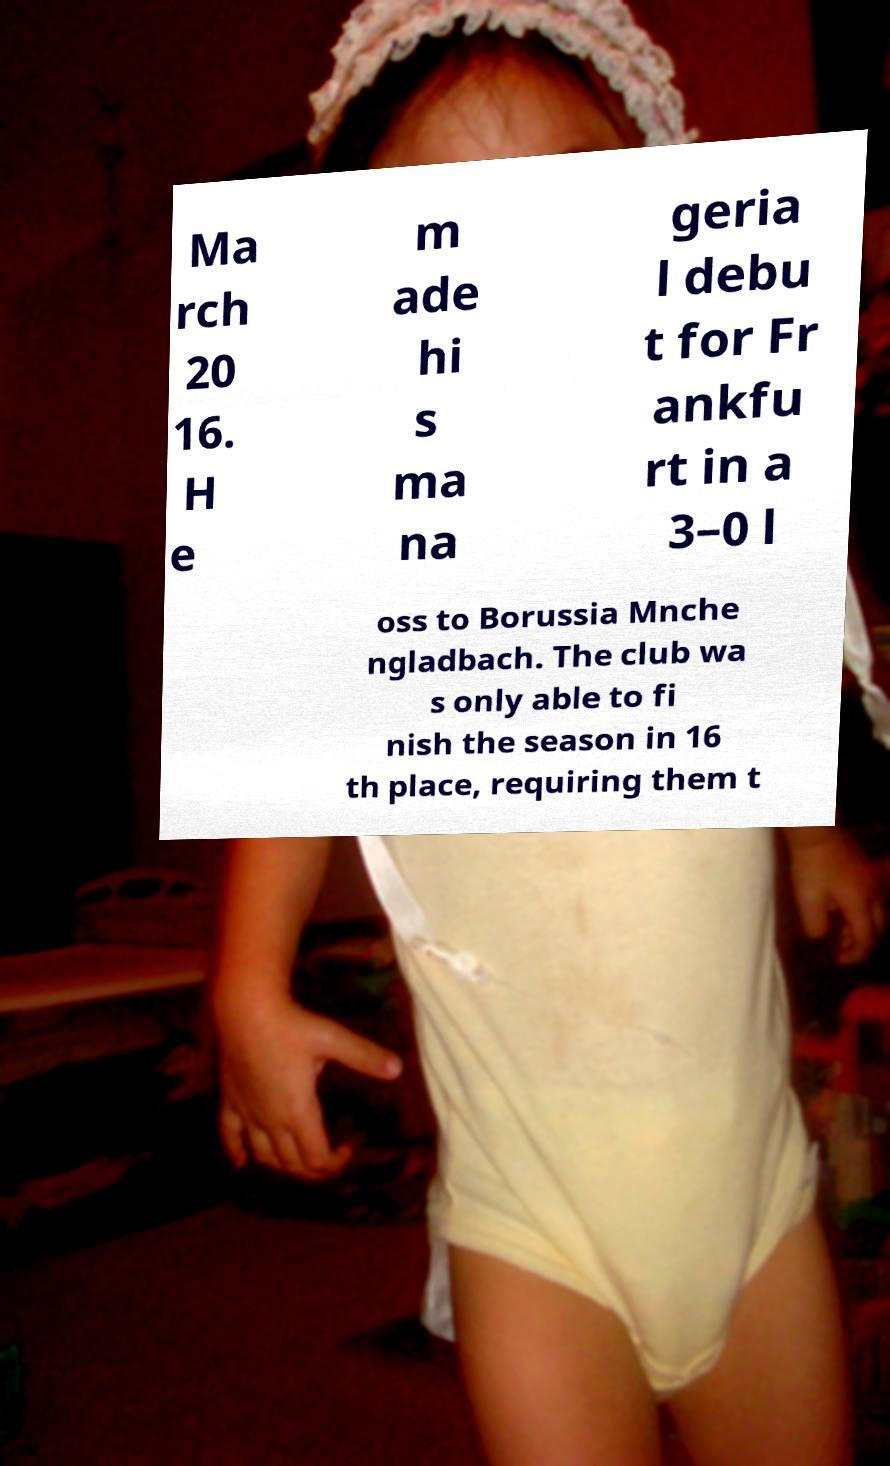Could you extract and type out the text from this image? Ma rch 20 16. H e m ade hi s ma na geria l debu t for Fr ankfu rt in a 3–0 l oss to Borussia Mnche ngladbach. The club wa s only able to fi nish the season in 16 th place, requiring them t 